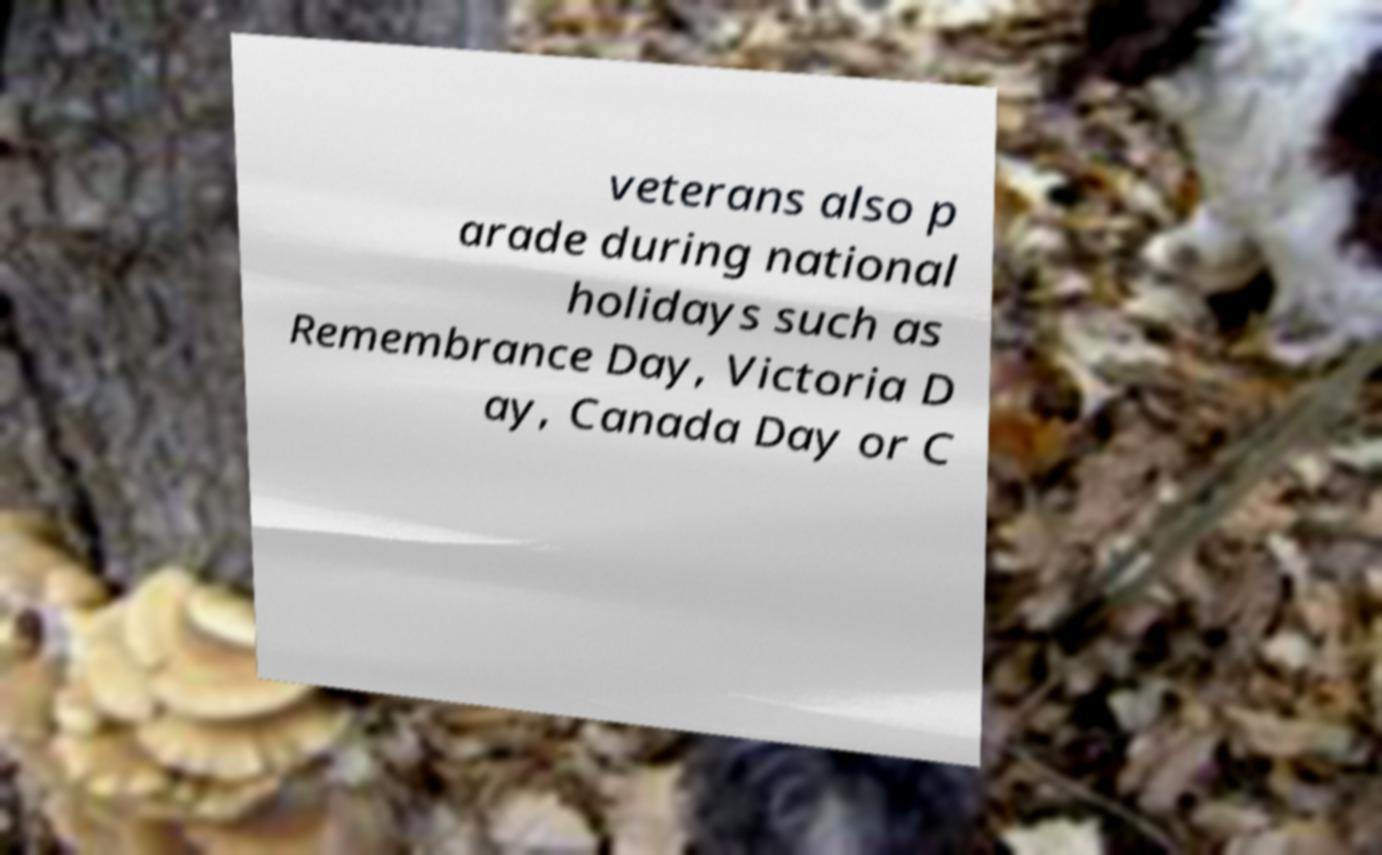Could you assist in decoding the text presented in this image and type it out clearly? veterans also p arade during national holidays such as Remembrance Day, Victoria D ay, Canada Day or C 